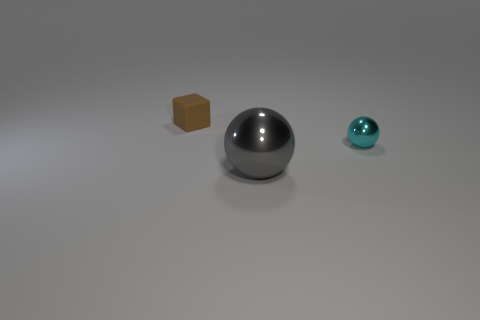Add 3 large purple rubber things. How many objects exist? 6 Subtract 1 blocks. How many blocks are left? 0 Subtract 0 cyan cylinders. How many objects are left? 3 Subtract all balls. How many objects are left? 1 Subtract all green cubes. Subtract all green cylinders. How many cubes are left? 1 Subtract all large red shiny cubes. Subtract all matte things. How many objects are left? 2 Add 1 brown rubber blocks. How many brown rubber blocks are left? 2 Add 1 brown cubes. How many brown cubes exist? 2 